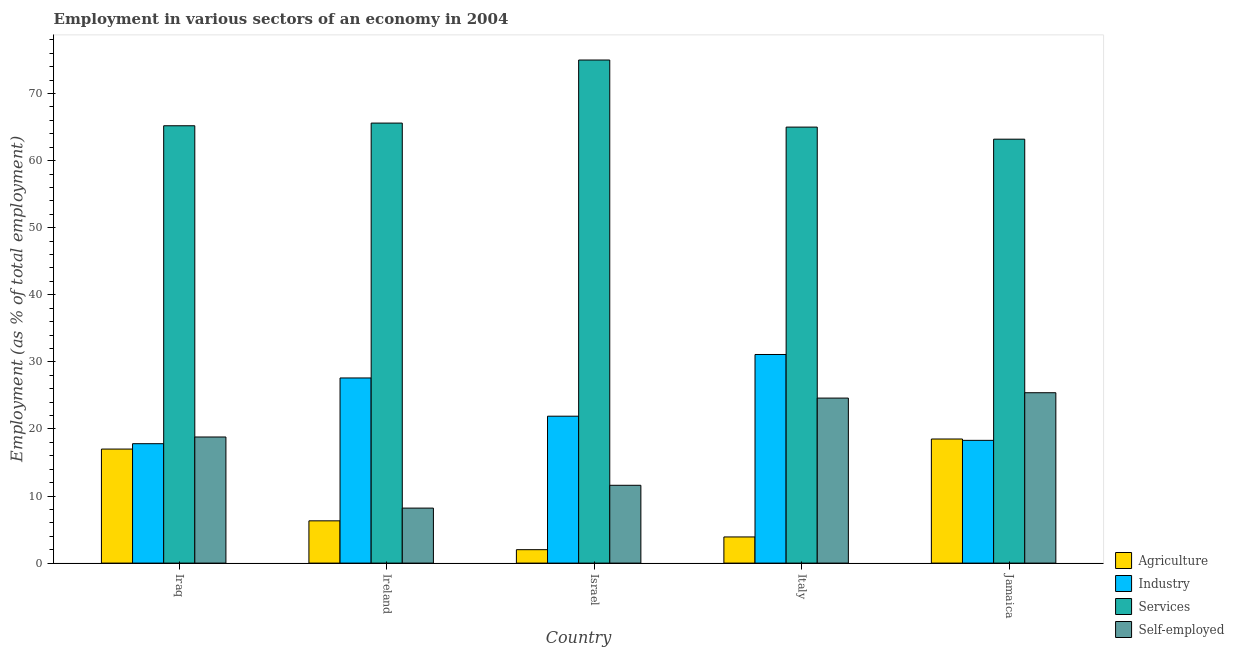How many different coloured bars are there?
Offer a very short reply. 4. What is the label of the 5th group of bars from the left?
Keep it short and to the point. Jamaica. In how many cases, is the number of bars for a given country not equal to the number of legend labels?
Keep it short and to the point. 0. What is the percentage of self employed workers in Jamaica?
Provide a short and direct response. 25.4. Across all countries, what is the maximum percentage of workers in industry?
Your response must be concise. 31.1. Across all countries, what is the minimum percentage of workers in industry?
Provide a short and direct response. 17.8. In which country was the percentage of workers in industry maximum?
Your response must be concise. Italy. In which country was the percentage of workers in industry minimum?
Your answer should be very brief. Iraq. What is the total percentage of self employed workers in the graph?
Provide a short and direct response. 88.6. What is the difference between the percentage of self employed workers in Iraq and that in Israel?
Offer a terse response. 7.2. What is the difference between the percentage of workers in agriculture in Jamaica and the percentage of workers in industry in Ireland?
Offer a very short reply. -9.1. What is the average percentage of workers in industry per country?
Keep it short and to the point. 23.34. What is the difference between the percentage of workers in services and percentage of self employed workers in Iraq?
Offer a terse response. 46.4. What is the ratio of the percentage of workers in agriculture in Ireland to that in Italy?
Ensure brevity in your answer.  1.62. Is the difference between the percentage of workers in services in Ireland and Israel greater than the difference between the percentage of self employed workers in Ireland and Israel?
Your response must be concise. No. What is the difference between the highest and the second highest percentage of self employed workers?
Make the answer very short. 0.8. Is the sum of the percentage of workers in industry in Israel and Italy greater than the maximum percentage of workers in services across all countries?
Provide a succinct answer. No. Is it the case that in every country, the sum of the percentage of workers in services and percentage of workers in industry is greater than the sum of percentage of workers in agriculture and percentage of self employed workers?
Ensure brevity in your answer.  Yes. What does the 4th bar from the left in Jamaica represents?
Your response must be concise. Self-employed. What does the 4th bar from the right in Italy represents?
Ensure brevity in your answer.  Agriculture. How many countries are there in the graph?
Offer a very short reply. 5. What is the difference between two consecutive major ticks on the Y-axis?
Ensure brevity in your answer.  10. Does the graph contain any zero values?
Make the answer very short. No. Where does the legend appear in the graph?
Provide a short and direct response. Bottom right. How many legend labels are there?
Ensure brevity in your answer.  4. How are the legend labels stacked?
Make the answer very short. Vertical. What is the title of the graph?
Your answer should be compact. Employment in various sectors of an economy in 2004. Does "Revenue mobilization" appear as one of the legend labels in the graph?
Provide a short and direct response. No. What is the label or title of the X-axis?
Provide a short and direct response. Country. What is the label or title of the Y-axis?
Provide a succinct answer. Employment (as % of total employment). What is the Employment (as % of total employment) of Agriculture in Iraq?
Provide a short and direct response. 17. What is the Employment (as % of total employment) in Industry in Iraq?
Your answer should be compact. 17.8. What is the Employment (as % of total employment) in Services in Iraq?
Your answer should be very brief. 65.2. What is the Employment (as % of total employment) in Self-employed in Iraq?
Offer a terse response. 18.8. What is the Employment (as % of total employment) of Agriculture in Ireland?
Ensure brevity in your answer.  6.3. What is the Employment (as % of total employment) in Industry in Ireland?
Make the answer very short. 27.6. What is the Employment (as % of total employment) in Services in Ireland?
Your response must be concise. 65.6. What is the Employment (as % of total employment) of Self-employed in Ireland?
Keep it short and to the point. 8.2. What is the Employment (as % of total employment) of Agriculture in Israel?
Your answer should be compact. 2. What is the Employment (as % of total employment) of Industry in Israel?
Offer a terse response. 21.9. What is the Employment (as % of total employment) of Services in Israel?
Offer a very short reply. 75. What is the Employment (as % of total employment) in Self-employed in Israel?
Keep it short and to the point. 11.6. What is the Employment (as % of total employment) in Agriculture in Italy?
Ensure brevity in your answer.  3.9. What is the Employment (as % of total employment) of Industry in Italy?
Ensure brevity in your answer.  31.1. What is the Employment (as % of total employment) in Services in Italy?
Your answer should be compact. 65. What is the Employment (as % of total employment) in Self-employed in Italy?
Provide a short and direct response. 24.6. What is the Employment (as % of total employment) of Agriculture in Jamaica?
Ensure brevity in your answer.  18.5. What is the Employment (as % of total employment) in Industry in Jamaica?
Your answer should be very brief. 18.3. What is the Employment (as % of total employment) in Services in Jamaica?
Provide a succinct answer. 63.2. What is the Employment (as % of total employment) of Self-employed in Jamaica?
Offer a terse response. 25.4. Across all countries, what is the maximum Employment (as % of total employment) in Agriculture?
Offer a terse response. 18.5. Across all countries, what is the maximum Employment (as % of total employment) in Industry?
Provide a succinct answer. 31.1. Across all countries, what is the maximum Employment (as % of total employment) in Self-employed?
Offer a very short reply. 25.4. Across all countries, what is the minimum Employment (as % of total employment) in Agriculture?
Ensure brevity in your answer.  2. Across all countries, what is the minimum Employment (as % of total employment) in Industry?
Make the answer very short. 17.8. Across all countries, what is the minimum Employment (as % of total employment) in Services?
Ensure brevity in your answer.  63.2. Across all countries, what is the minimum Employment (as % of total employment) of Self-employed?
Offer a very short reply. 8.2. What is the total Employment (as % of total employment) of Agriculture in the graph?
Provide a succinct answer. 47.7. What is the total Employment (as % of total employment) in Industry in the graph?
Provide a succinct answer. 116.7. What is the total Employment (as % of total employment) of Services in the graph?
Give a very brief answer. 334. What is the total Employment (as % of total employment) of Self-employed in the graph?
Your answer should be very brief. 88.6. What is the difference between the Employment (as % of total employment) of Self-employed in Iraq and that in Ireland?
Your response must be concise. 10.6. What is the difference between the Employment (as % of total employment) of Industry in Iraq and that in Israel?
Give a very brief answer. -4.1. What is the difference between the Employment (as % of total employment) of Services in Iraq and that in Israel?
Provide a short and direct response. -9.8. What is the difference between the Employment (as % of total employment) of Industry in Iraq and that in Italy?
Give a very brief answer. -13.3. What is the difference between the Employment (as % of total employment) in Self-employed in Iraq and that in Italy?
Provide a succinct answer. -5.8. What is the difference between the Employment (as % of total employment) of Industry in Iraq and that in Jamaica?
Offer a very short reply. -0.5. What is the difference between the Employment (as % of total employment) of Self-employed in Iraq and that in Jamaica?
Provide a succinct answer. -6.6. What is the difference between the Employment (as % of total employment) of Agriculture in Ireland and that in Italy?
Provide a short and direct response. 2.4. What is the difference between the Employment (as % of total employment) of Industry in Ireland and that in Italy?
Ensure brevity in your answer.  -3.5. What is the difference between the Employment (as % of total employment) in Services in Ireland and that in Italy?
Make the answer very short. 0.6. What is the difference between the Employment (as % of total employment) in Self-employed in Ireland and that in Italy?
Give a very brief answer. -16.4. What is the difference between the Employment (as % of total employment) of Services in Ireland and that in Jamaica?
Ensure brevity in your answer.  2.4. What is the difference between the Employment (as % of total employment) of Self-employed in Ireland and that in Jamaica?
Your answer should be very brief. -17.2. What is the difference between the Employment (as % of total employment) in Agriculture in Israel and that in Italy?
Make the answer very short. -1.9. What is the difference between the Employment (as % of total employment) in Industry in Israel and that in Italy?
Keep it short and to the point. -9.2. What is the difference between the Employment (as % of total employment) of Services in Israel and that in Italy?
Offer a very short reply. 10. What is the difference between the Employment (as % of total employment) of Agriculture in Israel and that in Jamaica?
Keep it short and to the point. -16.5. What is the difference between the Employment (as % of total employment) of Self-employed in Israel and that in Jamaica?
Your answer should be compact. -13.8. What is the difference between the Employment (as % of total employment) of Agriculture in Italy and that in Jamaica?
Your answer should be compact. -14.6. What is the difference between the Employment (as % of total employment) of Industry in Italy and that in Jamaica?
Provide a short and direct response. 12.8. What is the difference between the Employment (as % of total employment) in Services in Italy and that in Jamaica?
Make the answer very short. 1.8. What is the difference between the Employment (as % of total employment) of Self-employed in Italy and that in Jamaica?
Provide a succinct answer. -0.8. What is the difference between the Employment (as % of total employment) of Agriculture in Iraq and the Employment (as % of total employment) of Services in Ireland?
Offer a very short reply. -48.6. What is the difference between the Employment (as % of total employment) of Agriculture in Iraq and the Employment (as % of total employment) of Self-employed in Ireland?
Keep it short and to the point. 8.8. What is the difference between the Employment (as % of total employment) in Industry in Iraq and the Employment (as % of total employment) in Services in Ireland?
Your answer should be compact. -47.8. What is the difference between the Employment (as % of total employment) of Services in Iraq and the Employment (as % of total employment) of Self-employed in Ireland?
Offer a very short reply. 57. What is the difference between the Employment (as % of total employment) in Agriculture in Iraq and the Employment (as % of total employment) in Services in Israel?
Offer a terse response. -58. What is the difference between the Employment (as % of total employment) in Industry in Iraq and the Employment (as % of total employment) in Services in Israel?
Ensure brevity in your answer.  -57.2. What is the difference between the Employment (as % of total employment) of Services in Iraq and the Employment (as % of total employment) of Self-employed in Israel?
Offer a very short reply. 53.6. What is the difference between the Employment (as % of total employment) in Agriculture in Iraq and the Employment (as % of total employment) in Industry in Italy?
Ensure brevity in your answer.  -14.1. What is the difference between the Employment (as % of total employment) of Agriculture in Iraq and the Employment (as % of total employment) of Services in Italy?
Give a very brief answer. -48. What is the difference between the Employment (as % of total employment) in Industry in Iraq and the Employment (as % of total employment) in Services in Italy?
Provide a short and direct response. -47.2. What is the difference between the Employment (as % of total employment) in Industry in Iraq and the Employment (as % of total employment) in Self-employed in Italy?
Your response must be concise. -6.8. What is the difference between the Employment (as % of total employment) in Services in Iraq and the Employment (as % of total employment) in Self-employed in Italy?
Offer a very short reply. 40.6. What is the difference between the Employment (as % of total employment) of Agriculture in Iraq and the Employment (as % of total employment) of Industry in Jamaica?
Your response must be concise. -1.3. What is the difference between the Employment (as % of total employment) of Agriculture in Iraq and the Employment (as % of total employment) of Services in Jamaica?
Keep it short and to the point. -46.2. What is the difference between the Employment (as % of total employment) of Industry in Iraq and the Employment (as % of total employment) of Services in Jamaica?
Offer a very short reply. -45.4. What is the difference between the Employment (as % of total employment) of Industry in Iraq and the Employment (as % of total employment) of Self-employed in Jamaica?
Give a very brief answer. -7.6. What is the difference between the Employment (as % of total employment) in Services in Iraq and the Employment (as % of total employment) in Self-employed in Jamaica?
Offer a very short reply. 39.8. What is the difference between the Employment (as % of total employment) of Agriculture in Ireland and the Employment (as % of total employment) of Industry in Israel?
Provide a succinct answer. -15.6. What is the difference between the Employment (as % of total employment) of Agriculture in Ireland and the Employment (as % of total employment) of Services in Israel?
Give a very brief answer. -68.7. What is the difference between the Employment (as % of total employment) in Industry in Ireland and the Employment (as % of total employment) in Services in Israel?
Give a very brief answer. -47.4. What is the difference between the Employment (as % of total employment) of Industry in Ireland and the Employment (as % of total employment) of Self-employed in Israel?
Offer a terse response. 16. What is the difference between the Employment (as % of total employment) of Services in Ireland and the Employment (as % of total employment) of Self-employed in Israel?
Keep it short and to the point. 54. What is the difference between the Employment (as % of total employment) in Agriculture in Ireland and the Employment (as % of total employment) in Industry in Italy?
Provide a short and direct response. -24.8. What is the difference between the Employment (as % of total employment) of Agriculture in Ireland and the Employment (as % of total employment) of Services in Italy?
Offer a terse response. -58.7. What is the difference between the Employment (as % of total employment) of Agriculture in Ireland and the Employment (as % of total employment) of Self-employed in Italy?
Make the answer very short. -18.3. What is the difference between the Employment (as % of total employment) in Industry in Ireland and the Employment (as % of total employment) in Services in Italy?
Offer a terse response. -37.4. What is the difference between the Employment (as % of total employment) of Services in Ireland and the Employment (as % of total employment) of Self-employed in Italy?
Your answer should be very brief. 41. What is the difference between the Employment (as % of total employment) in Agriculture in Ireland and the Employment (as % of total employment) in Industry in Jamaica?
Offer a terse response. -12. What is the difference between the Employment (as % of total employment) in Agriculture in Ireland and the Employment (as % of total employment) in Services in Jamaica?
Provide a succinct answer. -56.9. What is the difference between the Employment (as % of total employment) in Agriculture in Ireland and the Employment (as % of total employment) in Self-employed in Jamaica?
Give a very brief answer. -19.1. What is the difference between the Employment (as % of total employment) in Industry in Ireland and the Employment (as % of total employment) in Services in Jamaica?
Offer a very short reply. -35.6. What is the difference between the Employment (as % of total employment) in Services in Ireland and the Employment (as % of total employment) in Self-employed in Jamaica?
Your answer should be very brief. 40.2. What is the difference between the Employment (as % of total employment) of Agriculture in Israel and the Employment (as % of total employment) of Industry in Italy?
Keep it short and to the point. -29.1. What is the difference between the Employment (as % of total employment) in Agriculture in Israel and the Employment (as % of total employment) in Services in Italy?
Offer a terse response. -63. What is the difference between the Employment (as % of total employment) in Agriculture in Israel and the Employment (as % of total employment) in Self-employed in Italy?
Your answer should be very brief. -22.6. What is the difference between the Employment (as % of total employment) of Industry in Israel and the Employment (as % of total employment) of Services in Italy?
Provide a succinct answer. -43.1. What is the difference between the Employment (as % of total employment) of Services in Israel and the Employment (as % of total employment) of Self-employed in Italy?
Offer a terse response. 50.4. What is the difference between the Employment (as % of total employment) in Agriculture in Israel and the Employment (as % of total employment) in Industry in Jamaica?
Offer a very short reply. -16.3. What is the difference between the Employment (as % of total employment) of Agriculture in Israel and the Employment (as % of total employment) of Services in Jamaica?
Your response must be concise. -61.2. What is the difference between the Employment (as % of total employment) in Agriculture in Israel and the Employment (as % of total employment) in Self-employed in Jamaica?
Make the answer very short. -23.4. What is the difference between the Employment (as % of total employment) of Industry in Israel and the Employment (as % of total employment) of Services in Jamaica?
Provide a succinct answer. -41.3. What is the difference between the Employment (as % of total employment) of Industry in Israel and the Employment (as % of total employment) of Self-employed in Jamaica?
Make the answer very short. -3.5. What is the difference between the Employment (as % of total employment) of Services in Israel and the Employment (as % of total employment) of Self-employed in Jamaica?
Your response must be concise. 49.6. What is the difference between the Employment (as % of total employment) of Agriculture in Italy and the Employment (as % of total employment) of Industry in Jamaica?
Provide a succinct answer. -14.4. What is the difference between the Employment (as % of total employment) of Agriculture in Italy and the Employment (as % of total employment) of Services in Jamaica?
Your answer should be very brief. -59.3. What is the difference between the Employment (as % of total employment) in Agriculture in Italy and the Employment (as % of total employment) in Self-employed in Jamaica?
Ensure brevity in your answer.  -21.5. What is the difference between the Employment (as % of total employment) in Industry in Italy and the Employment (as % of total employment) in Services in Jamaica?
Offer a terse response. -32.1. What is the difference between the Employment (as % of total employment) in Industry in Italy and the Employment (as % of total employment) in Self-employed in Jamaica?
Provide a short and direct response. 5.7. What is the difference between the Employment (as % of total employment) in Services in Italy and the Employment (as % of total employment) in Self-employed in Jamaica?
Your answer should be compact. 39.6. What is the average Employment (as % of total employment) of Agriculture per country?
Ensure brevity in your answer.  9.54. What is the average Employment (as % of total employment) of Industry per country?
Ensure brevity in your answer.  23.34. What is the average Employment (as % of total employment) in Services per country?
Provide a succinct answer. 66.8. What is the average Employment (as % of total employment) of Self-employed per country?
Ensure brevity in your answer.  17.72. What is the difference between the Employment (as % of total employment) in Agriculture and Employment (as % of total employment) in Services in Iraq?
Your answer should be compact. -48.2. What is the difference between the Employment (as % of total employment) of Industry and Employment (as % of total employment) of Services in Iraq?
Offer a very short reply. -47.4. What is the difference between the Employment (as % of total employment) in Industry and Employment (as % of total employment) in Self-employed in Iraq?
Make the answer very short. -1. What is the difference between the Employment (as % of total employment) of Services and Employment (as % of total employment) of Self-employed in Iraq?
Provide a succinct answer. 46.4. What is the difference between the Employment (as % of total employment) of Agriculture and Employment (as % of total employment) of Industry in Ireland?
Your answer should be compact. -21.3. What is the difference between the Employment (as % of total employment) of Agriculture and Employment (as % of total employment) of Services in Ireland?
Provide a short and direct response. -59.3. What is the difference between the Employment (as % of total employment) in Agriculture and Employment (as % of total employment) in Self-employed in Ireland?
Offer a terse response. -1.9. What is the difference between the Employment (as % of total employment) of Industry and Employment (as % of total employment) of Services in Ireland?
Provide a succinct answer. -38. What is the difference between the Employment (as % of total employment) of Industry and Employment (as % of total employment) of Self-employed in Ireland?
Provide a short and direct response. 19.4. What is the difference between the Employment (as % of total employment) of Services and Employment (as % of total employment) of Self-employed in Ireland?
Offer a terse response. 57.4. What is the difference between the Employment (as % of total employment) of Agriculture and Employment (as % of total employment) of Industry in Israel?
Offer a very short reply. -19.9. What is the difference between the Employment (as % of total employment) of Agriculture and Employment (as % of total employment) of Services in Israel?
Ensure brevity in your answer.  -73. What is the difference between the Employment (as % of total employment) in Agriculture and Employment (as % of total employment) in Self-employed in Israel?
Keep it short and to the point. -9.6. What is the difference between the Employment (as % of total employment) in Industry and Employment (as % of total employment) in Services in Israel?
Give a very brief answer. -53.1. What is the difference between the Employment (as % of total employment) of Services and Employment (as % of total employment) of Self-employed in Israel?
Offer a very short reply. 63.4. What is the difference between the Employment (as % of total employment) in Agriculture and Employment (as % of total employment) in Industry in Italy?
Your response must be concise. -27.2. What is the difference between the Employment (as % of total employment) in Agriculture and Employment (as % of total employment) in Services in Italy?
Provide a short and direct response. -61.1. What is the difference between the Employment (as % of total employment) in Agriculture and Employment (as % of total employment) in Self-employed in Italy?
Provide a succinct answer. -20.7. What is the difference between the Employment (as % of total employment) in Industry and Employment (as % of total employment) in Services in Italy?
Your response must be concise. -33.9. What is the difference between the Employment (as % of total employment) of Industry and Employment (as % of total employment) of Self-employed in Italy?
Keep it short and to the point. 6.5. What is the difference between the Employment (as % of total employment) in Services and Employment (as % of total employment) in Self-employed in Italy?
Your answer should be compact. 40.4. What is the difference between the Employment (as % of total employment) in Agriculture and Employment (as % of total employment) in Services in Jamaica?
Make the answer very short. -44.7. What is the difference between the Employment (as % of total employment) in Industry and Employment (as % of total employment) in Services in Jamaica?
Provide a short and direct response. -44.9. What is the difference between the Employment (as % of total employment) in Services and Employment (as % of total employment) in Self-employed in Jamaica?
Make the answer very short. 37.8. What is the ratio of the Employment (as % of total employment) in Agriculture in Iraq to that in Ireland?
Your answer should be very brief. 2.7. What is the ratio of the Employment (as % of total employment) in Industry in Iraq to that in Ireland?
Provide a succinct answer. 0.64. What is the ratio of the Employment (as % of total employment) of Services in Iraq to that in Ireland?
Keep it short and to the point. 0.99. What is the ratio of the Employment (as % of total employment) of Self-employed in Iraq to that in Ireland?
Provide a succinct answer. 2.29. What is the ratio of the Employment (as % of total employment) in Agriculture in Iraq to that in Israel?
Your response must be concise. 8.5. What is the ratio of the Employment (as % of total employment) of Industry in Iraq to that in Israel?
Your response must be concise. 0.81. What is the ratio of the Employment (as % of total employment) of Services in Iraq to that in Israel?
Keep it short and to the point. 0.87. What is the ratio of the Employment (as % of total employment) of Self-employed in Iraq to that in Israel?
Ensure brevity in your answer.  1.62. What is the ratio of the Employment (as % of total employment) of Agriculture in Iraq to that in Italy?
Your answer should be compact. 4.36. What is the ratio of the Employment (as % of total employment) of Industry in Iraq to that in Italy?
Make the answer very short. 0.57. What is the ratio of the Employment (as % of total employment) in Self-employed in Iraq to that in Italy?
Offer a very short reply. 0.76. What is the ratio of the Employment (as % of total employment) of Agriculture in Iraq to that in Jamaica?
Offer a terse response. 0.92. What is the ratio of the Employment (as % of total employment) of Industry in Iraq to that in Jamaica?
Keep it short and to the point. 0.97. What is the ratio of the Employment (as % of total employment) of Services in Iraq to that in Jamaica?
Keep it short and to the point. 1.03. What is the ratio of the Employment (as % of total employment) of Self-employed in Iraq to that in Jamaica?
Give a very brief answer. 0.74. What is the ratio of the Employment (as % of total employment) in Agriculture in Ireland to that in Israel?
Ensure brevity in your answer.  3.15. What is the ratio of the Employment (as % of total employment) in Industry in Ireland to that in Israel?
Give a very brief answer. 1.26. What is the ratio of the Employment (as % of total employment) of Services in Ireland to that in Israel?
Make the answer very short. 0.87. What is the ratio of the Employment (as % of total employment) in Self-employed in Ireland to that in Israel?
Your response must be concise. 0.71. What is the ratio of the Employment (as % of total employment) in Agriculture in Ireland to that in Italy?
Offer a terse response. 1.62. What is the ratio of the Employment (as % of total employment) of Industry in Ireland to that in Italy?
Provide a succinct answer. 0.89. What is the ratio of the Employment (as % of total employment) of Services in Ireland to that in Italy?
Your answer should be very brief. 1.01. What is the ratio of the Employment (as % of total employment) of Agriculture in Ireland to that in Jamaica?
Your response must be concise. 0.34. What is the ratio of the Employment (as % of total employment) of Industry in Ireland to that in Jamaica?
Your answer should be very brief. 1.51. What is the ratio of the Employment (as % of total employment) in Services in Ireland to that in Jamaica?
Offer a terse response. 1.04. What is the ratio of the Employment (as % of total employment) in Self-employed in Ireland to that in Jamaica?
Offer a terse response. 0.32. What is the ratio of the Employment (as % of total employment) of Agriculture in Israel to that in Italy?
Your response must be concise. 0.51. What is the ratio of the Employment (as % of total employment) in Industry in Israel to that in Italy?
Your answer should be compact. 0.7. What is the ratio of the Employment (as % of total employment) in Services in Israel to that in Italy?
Offer a terse response. 1.15. What is the ratio of the Employment (as % of total employment) of Self-employed in Israel to that in Italy?
Provide a succinct answer. 0.47. What is the ratio of the Employment (as % of total employment) of Agriculture in Israel to that in Jamaica?
Your response must be concise. 0.11. What is the ratio of the Employment (as % of total employment) of Industry in Israel to that in Jamaica?
Your answer should be compact. 1.2. What is the ratio of the Employment (as % of total employment) of Services in Israel to that in Jamaica?
Ensure brevity in your answer.  1.19. What is the ratio of the Employment (as % of total employment) of Self-employed in Israel to that in Jamaica?
Your answer should be compact. 0.46. What is the ratio of the Employment (as % of total employment) of Agriculture in Italy to that in Jamaica?
Provide a short and direct response. 0.21. What is the ratio of the Employment (as % of total employment) in Industry in Italy to that in Jamaica?
Your response must be concise. 1.7. What is the ratio of the Employment (as % of total employment) of Services in Italy to that in Jamaica?
Offer a very short reply. 1.03. What is the ratio of the Employment (as % of total employment) in Self-employed in Italy to that in Jamaica?
Your answer should be compact. 0.97. What is the difference between the highest and the second highest Employment (as % of total employment) in Agriculture?
Ensure brevity in your answer.  1.5. What is the difference between the highest and the second highest Employment (as % of total employment) of Services?
Give a very brief answer. 9.4. What is the difference between the highest and the lowest Employment (as % of total employment) of Agriculture?
Keep it short and to the point. 16.5. What is the difference between the highest and the lowest Employment (as % of total employment) in Industry?
Ensure brevity in your answer.  13.3. What is the difference between the highest and the lowest Employment (as % of total employment) in Self-employed?
Provide a succinct answer. 17.2. 